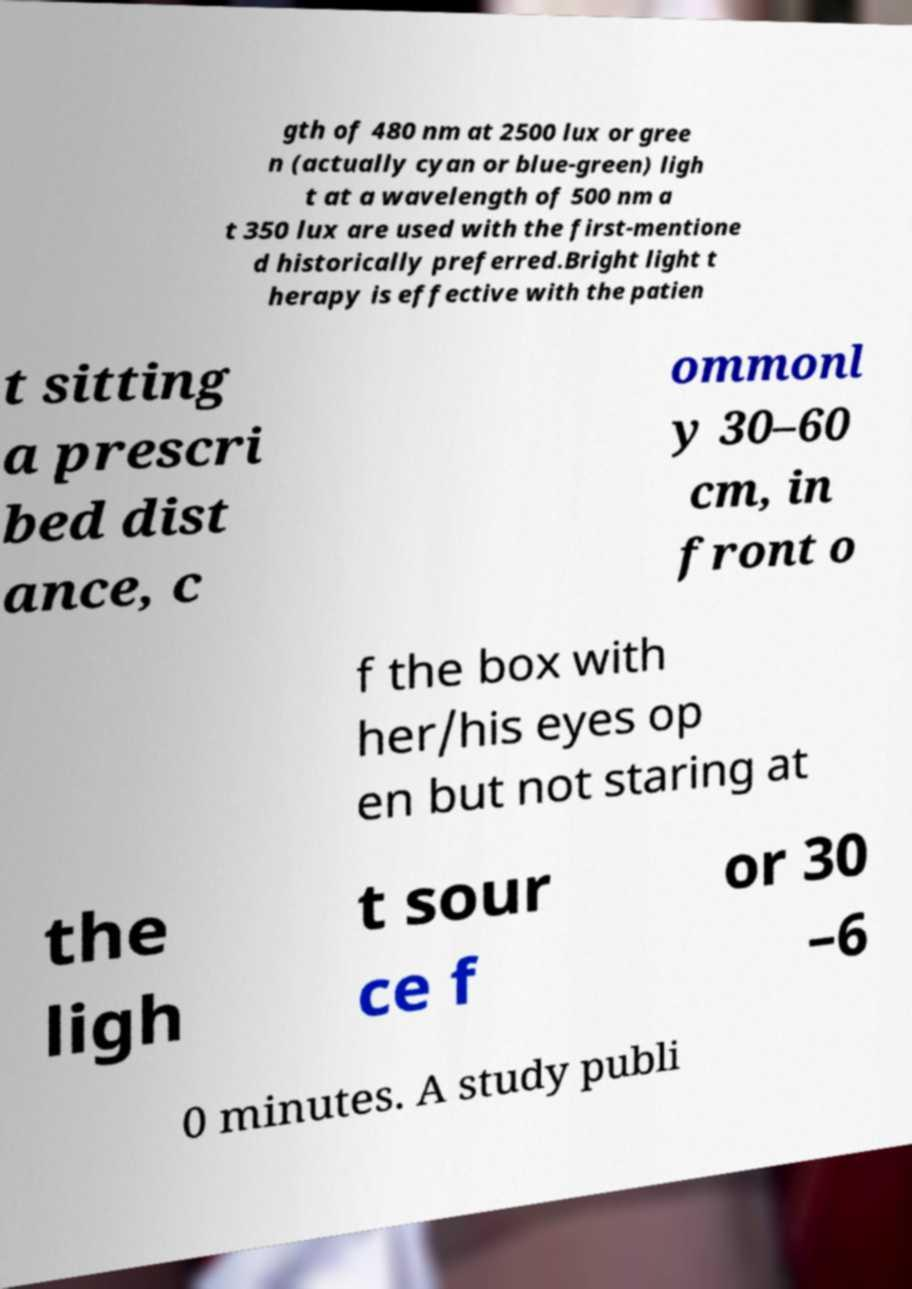Please read and relay the text visible in this image. What does it say? gth of 480 nm at 2500 lux or gree n (actually cyan or blue-green) ligh t at a wavelength of 500 nm a t 350 lux are used with the first-mentione d historically preferred.Bright light t herapy is effective with the patien t sitting a prescri bed dist ance, c ommonl y 30–60 cm, in front o f the box with her/his eyes op en but not staring at the ligh t sour ce f or 30 –6 0 minutes. A study publi 